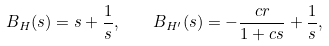<formula> <loc_0><loc_0><loc_500><loc_500>B _ { H } ( s ) = s + \frac { 1 } { s } , \quad B _ { H ^ { \prime } } ( s ) = - \frac { c r } { 1 + c s } + \frac { 1 } { s } ,</formula> 